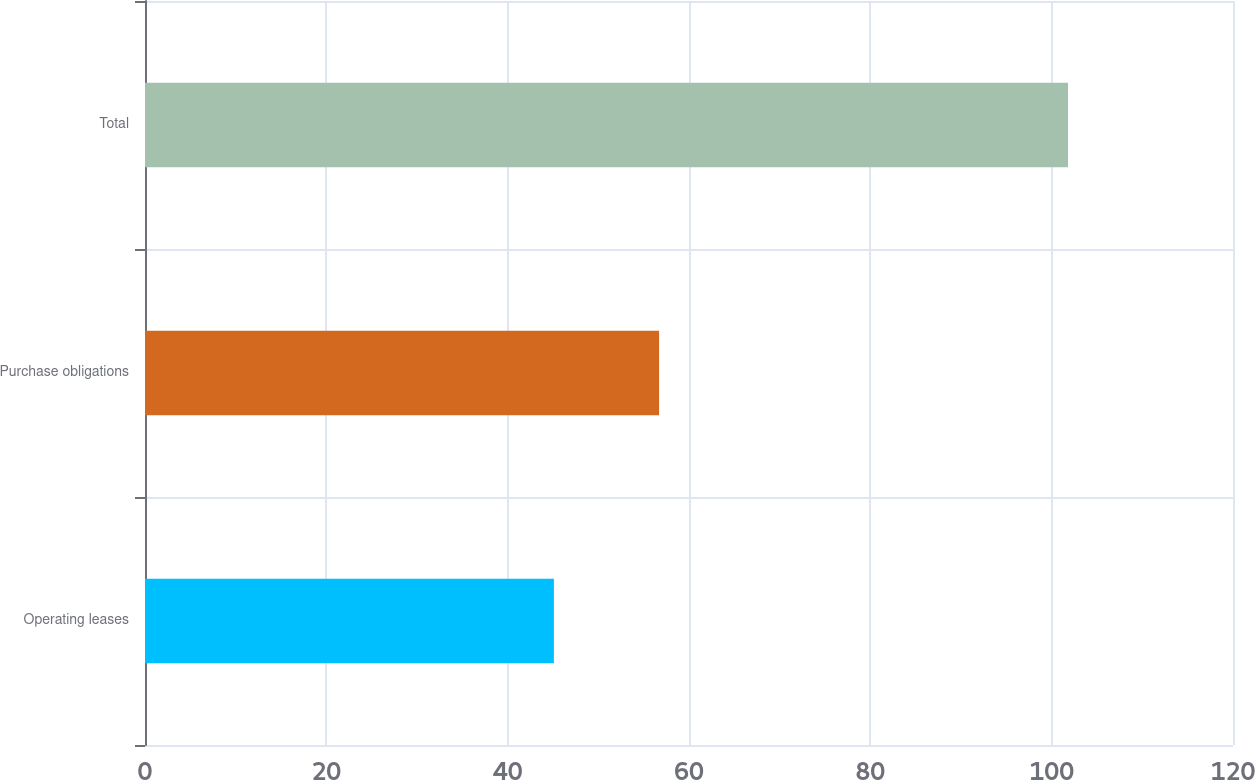Convert chart to OTSL. <chart><loc_0><loc_0><loc_500><loc_500><bar_chart><fcel>Operating leases<fcel>Purchase obligations<fcel>Total<nl><fcel>45.1<fcel>56.7<fcel>101.8<nl></chart> 